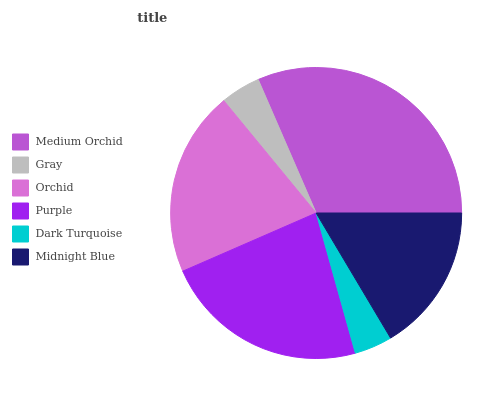Is Dark Turquoise the minimum?
Answer yes or no. Yes. Is Medium Orchid the maximum?
Answer yes or no. Yes. Is Gray the minimum?
Answer yes or no. No. Is Gray the maximum?
Answer yes or no. No. Is Medium Orchid greater than Gray?
Answer yes or no. Yes. Is Gray less than Medium Orchid?
Answer yes or no. Yes. Is Gray greater than Medium Orchid?
Answer yes or no. No. Is Medium Orchid less than Gray?
Answer yes or no. No. Is Orchid the high median?
Answer yes or no. Yes. Is Midnight Blue the low median?
Answer yes or no. Yes. Is Midnight Blue the high median?
Answer yes or no. No. Is Gray the low median?
Answer yes or no. No. 